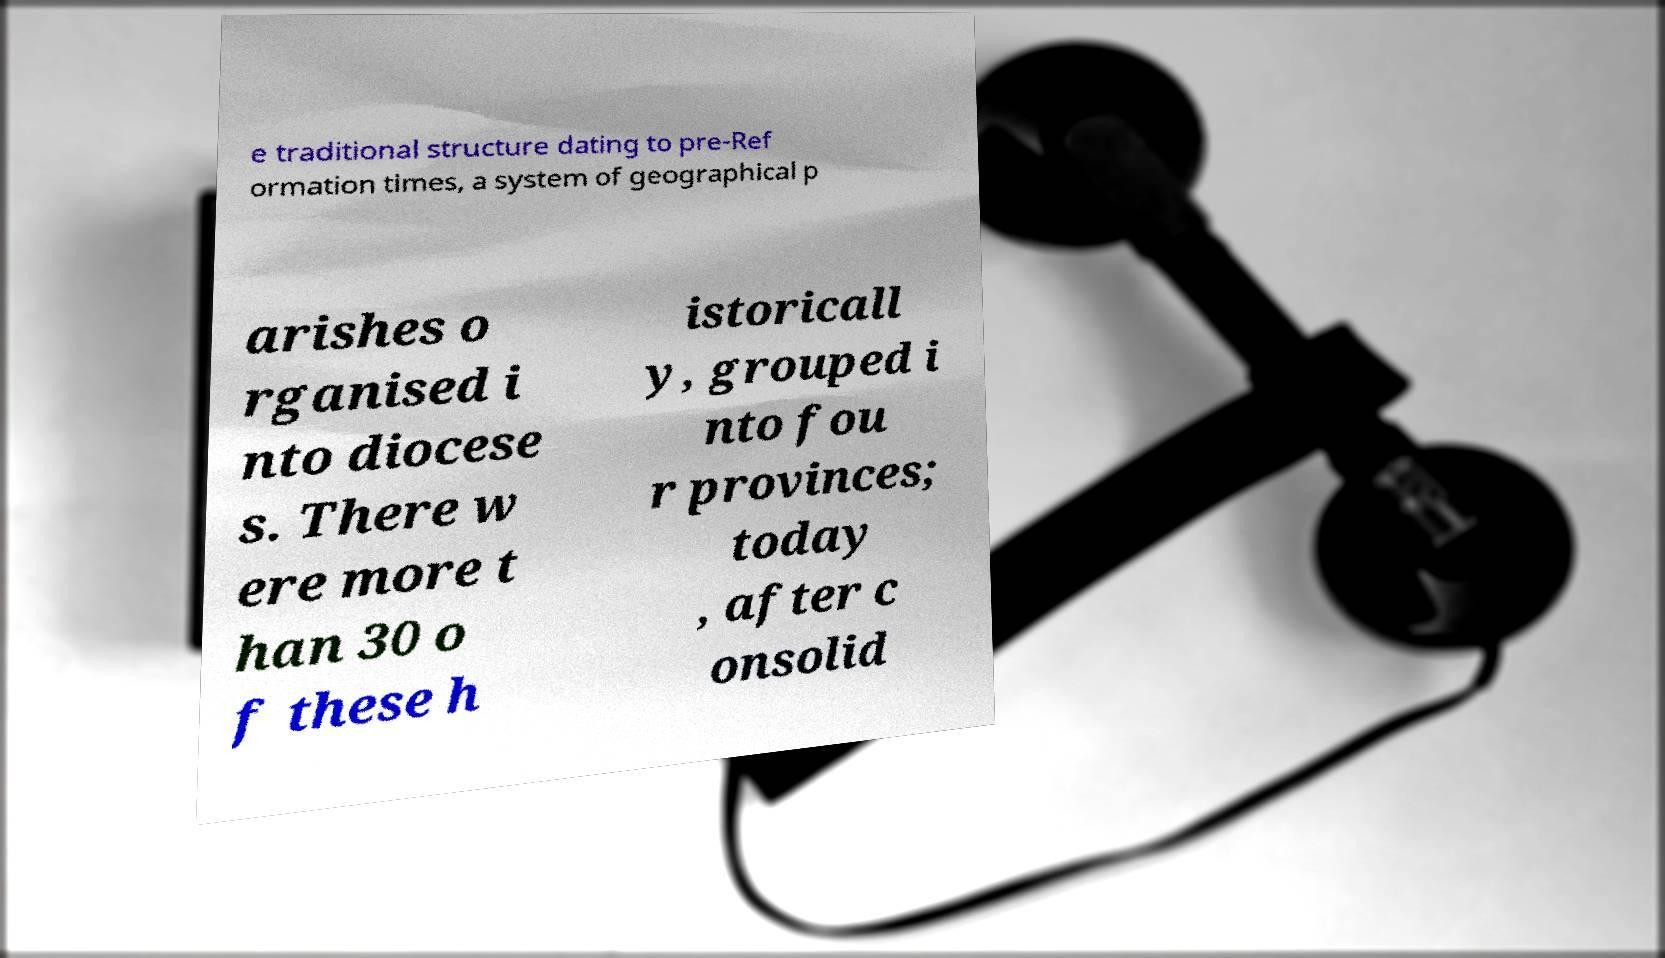For documentation purposes, I need the text within this image transcribed. Could you provide that? e traditional structure dating to pre-Ref ormation times, a system of geographical p arishes o rganised i nto diocese s. There w ere more t han 30 o f these h istoricall y, grouped i nto fou r provinces; today , after c onsolid 